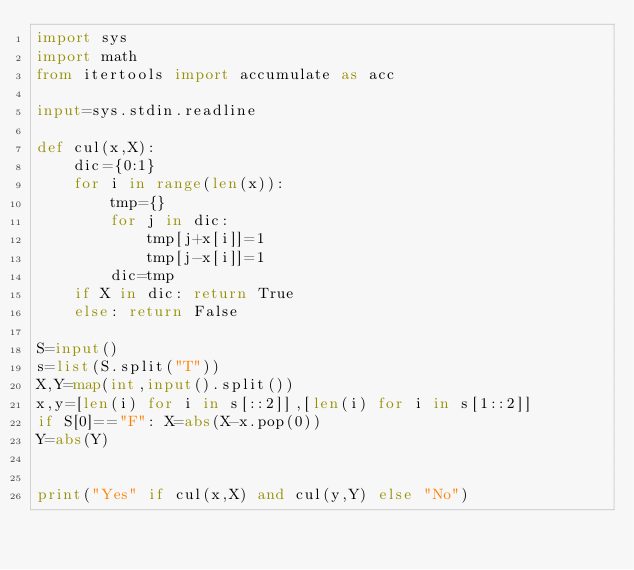<code> <loc_0><loc_0><loc_500><loc_500><_Python_>import sys
import math
from itertools import accumulate as acc

input=sys.stdin.readline

def cul(x,X):
    dic={0:1}
    for i in range(len(x)):
        tmp={}
        for j in dic:
            tmp[j+x[i]]=1
            tmp[j-x[i]]=1
        dic=tmp
    if X in dic: return True
    else: return False

S=input()
s=list(S.split("T"))
X,Y=map(int,input().split())
x,y=[len(i) for i in s[::2]],[len(i) for i in s[1::2]]
if S[0]=="F": X=abs(X-x.pop(0))
Y=abs(Y)


print("Yes" if cul(x,X) and cul(y,Y) else "No")</code> 